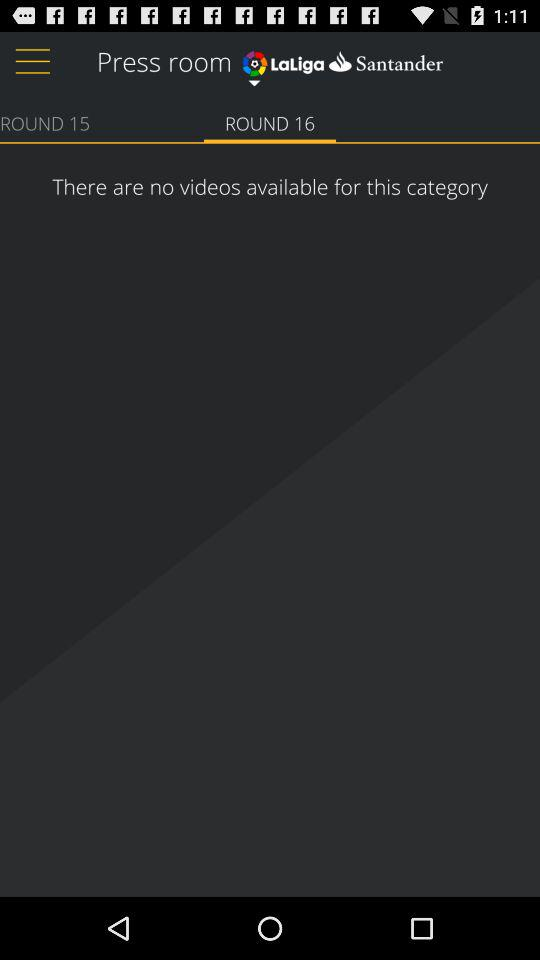How many videos are in "ROUND 15"?
When the provided information is insufficient, respond with <no answer>. <no answer> 